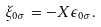<formula> <loc_0><loc_0><loc_500><loc_500>\xi _ { 0 \sigma } = - X \epsilon _ { 0 \sigma } .</formula> 